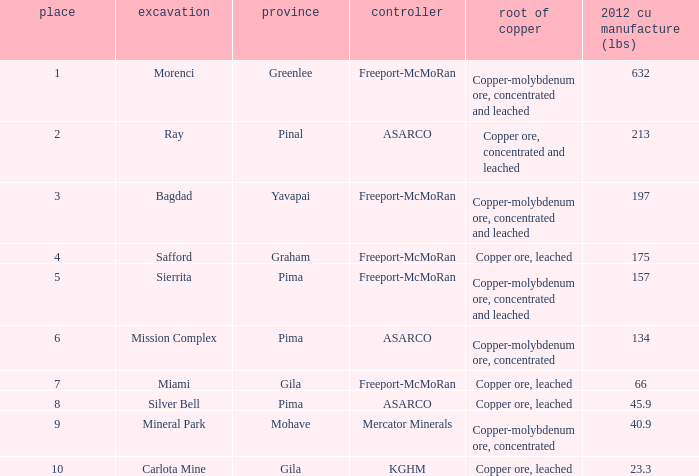What's the lowest ranking source of copper, copper ore, concentrated and leached? 2.0. 